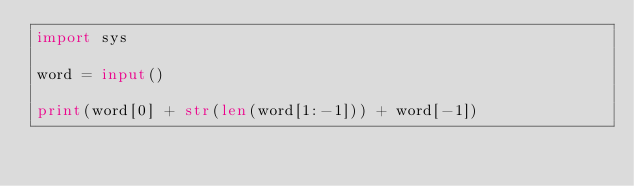<code> <loc_0><loc_0><loc_500><loc_500><_Python_>import sys

word = input()

print(word[0] + str(len(word[1:-1])) + word[-1])</code> 